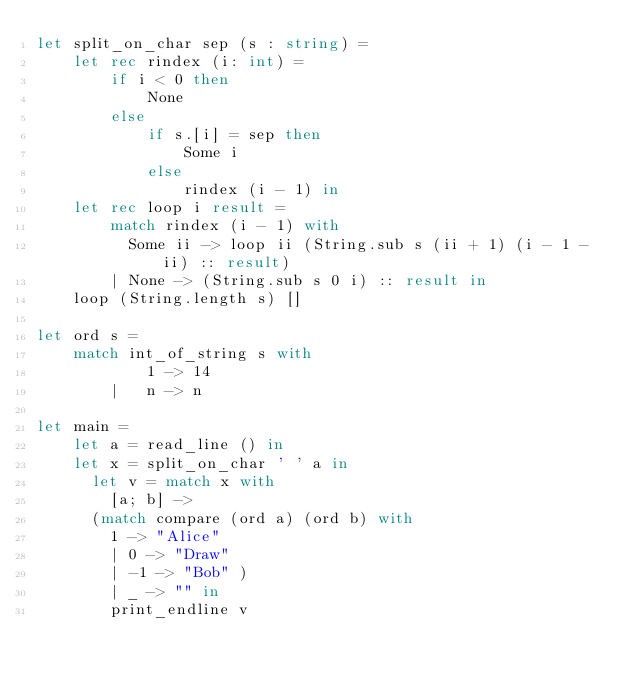Convert code to text. <code><loc_0><loc_0><loc_500><loc_500><_OCaml_>let split_on_char sep (s : string) =
    let rec rindex (i: int) =
        if i < 0 then
            None
        else
            if s.[i] = sep then
                Some i
            else
                rindex (i - 1) in
    let rec loop i result =
        match rindex (i - 1) with
          Some ii -> loop ii (String.sub s (ii + 1) (i - 1 - ii) :: result)
        | None -> (String.sub s 0 i) :: result in
    loop (String.length s) []

let ord s = 
    match int_of_string s with
            1 -> 14
        |   n -> n

let main =
    let a = read_line () in
    let x = split_on_char ' ' a in 
      let v = match x with
        [a; b] ->
      (match compare (ord a) (ord b) with
        1 -> "Alice"
        | 0 -> "Draw"
        | -1 -> "Bob" )
        | _ -> "" in 
        print_endline v
</code> 